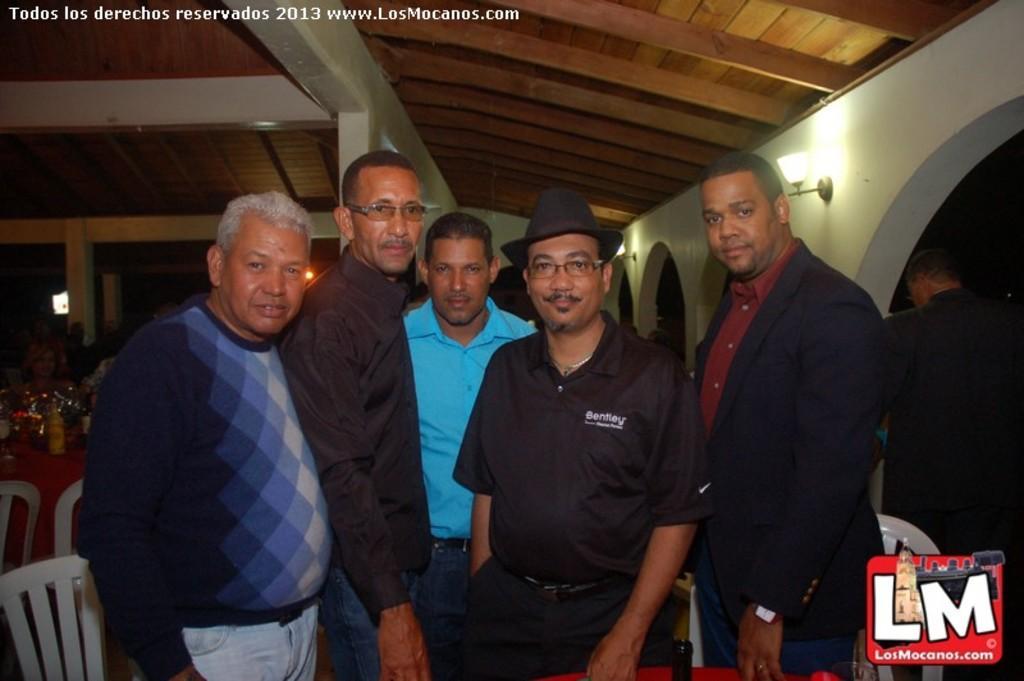Can you describe this image briefly? In this picture I can observe a man standing on the floor. One of them is wearing black color hat on his head. Two of them are wearing spectacles. There are chairs behind them. On the right side I can observe a lamp fixed to the wall. In the background I can observe wooden ceiling. There is some text on the top of the picture. 